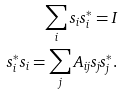Convert formula to latex. <formula><loc_0><loc_0><loc_500><loc_500>\sum _ { i } s _ { i } s _ { i } ^ { * } = I \\ s _ { i } ^ { * } s _ { i } = \sum _ { j } A _ { i j } s _ { j } s _ { j } ^ { * } .</formula> 